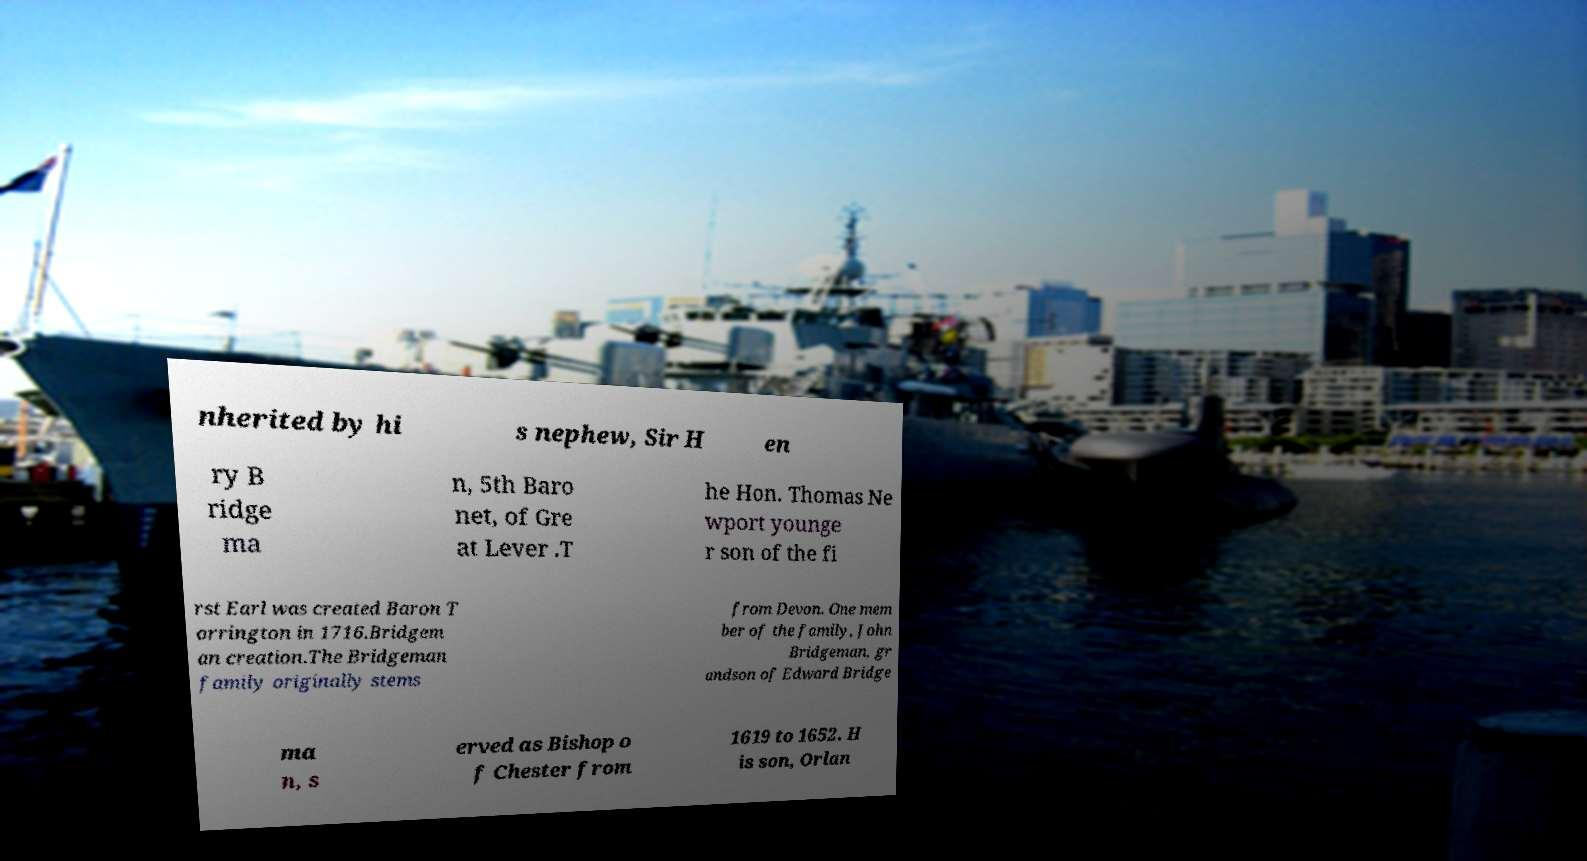Could you assist in decoding the text presented in this image and type it out clearly? nherited by hi s nephew, Sir H en ry B ridge ma n, 5th Baro net, of Gre at Lever .T he Hon. Thomas Ne wport younge r son of the fi rst Earl was created Baron T orrington in 1716.Bridgem an creation.The Bridgeman family originally stems from Devon. One mem ber of the family, John Bridgeman, gr andson of Edward Bridge ma n, s erved as Bishop o f Chester from 1619 to 1652. H is son, Orlan 